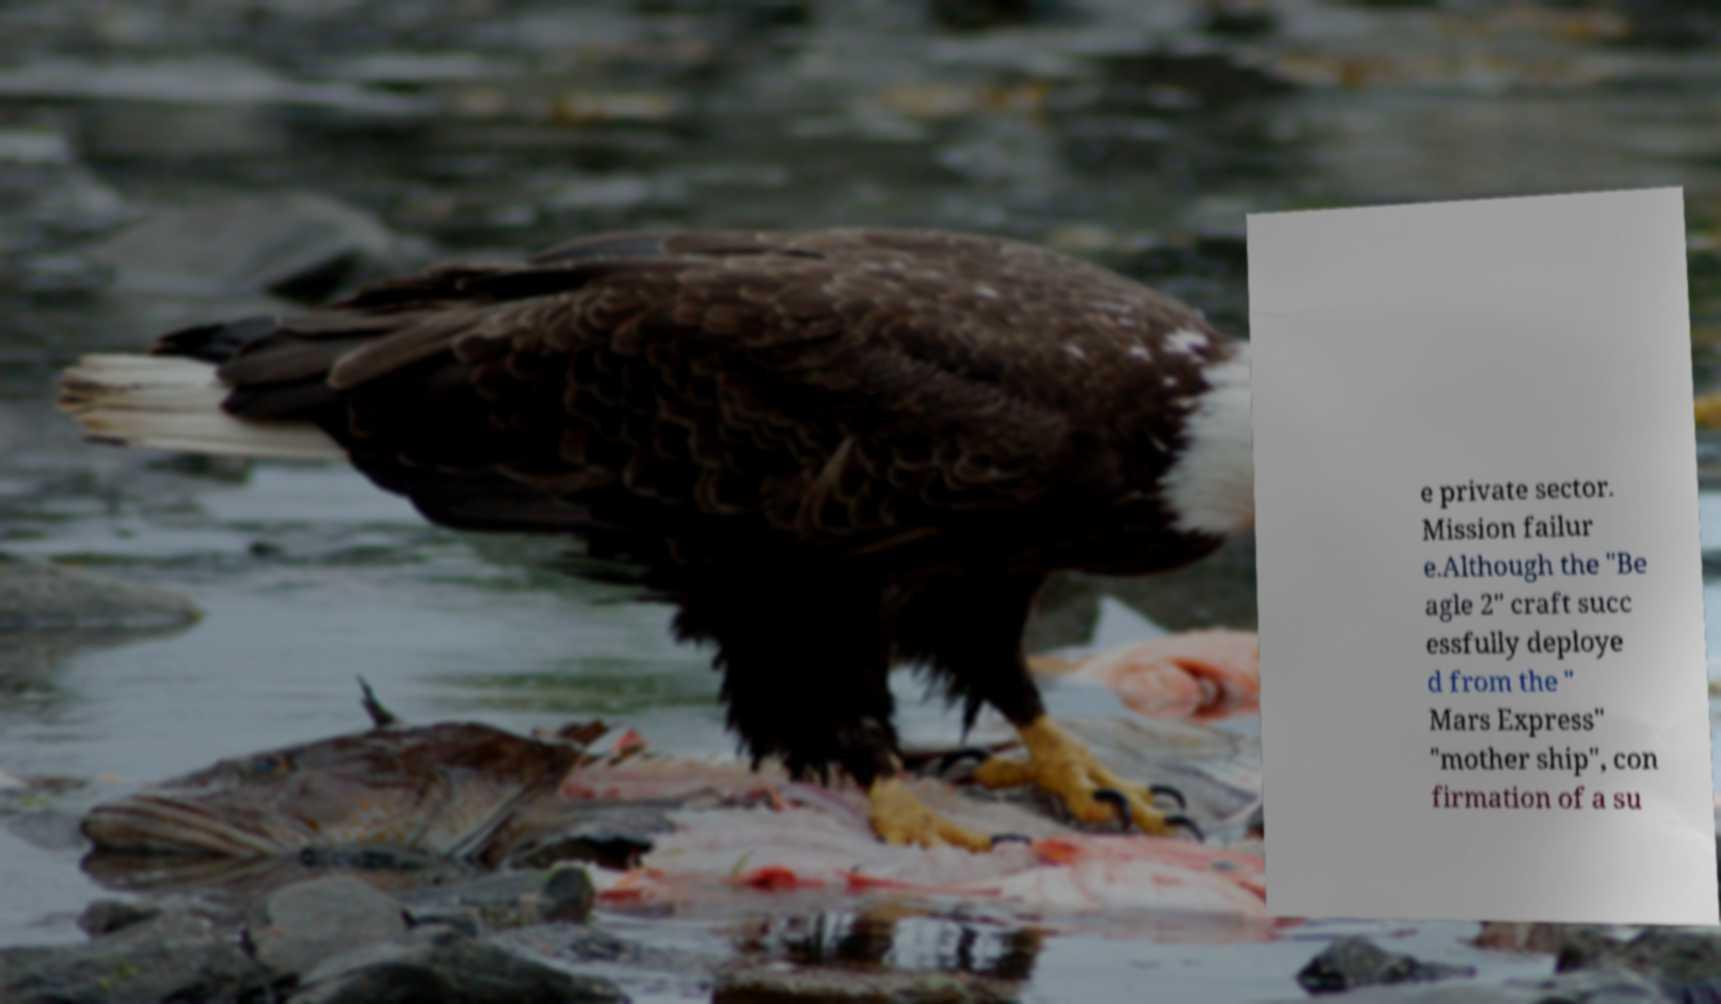Can you accurately transcribe the text from the provided image for me? e private sector. Mission failur e.Although the "Be agle 2" craft succ essfully deploye d from the " Mars Express" "mother ship", con firmation of a su 